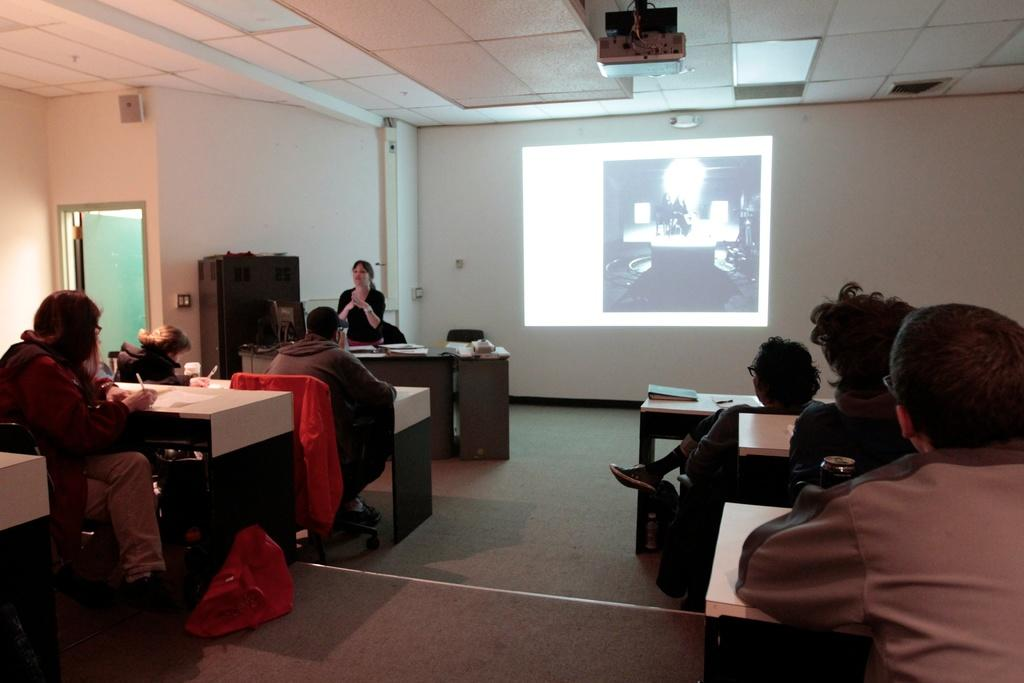How many people are in the image? There is a group of people in the image. What are the people doing in the image? The people are sitting in chairs. Where are the chairs located in relation to the table? The chairs are near a table. What can be seen in the background of the image? There is a projector, a screen, and a door in the background of the image. Can you tell me how many elbows are visible on the people in the image? It is impossible to determine the exact number of elbows visible on the people in the image, as the positioning of their arms and bodies is not clear. 